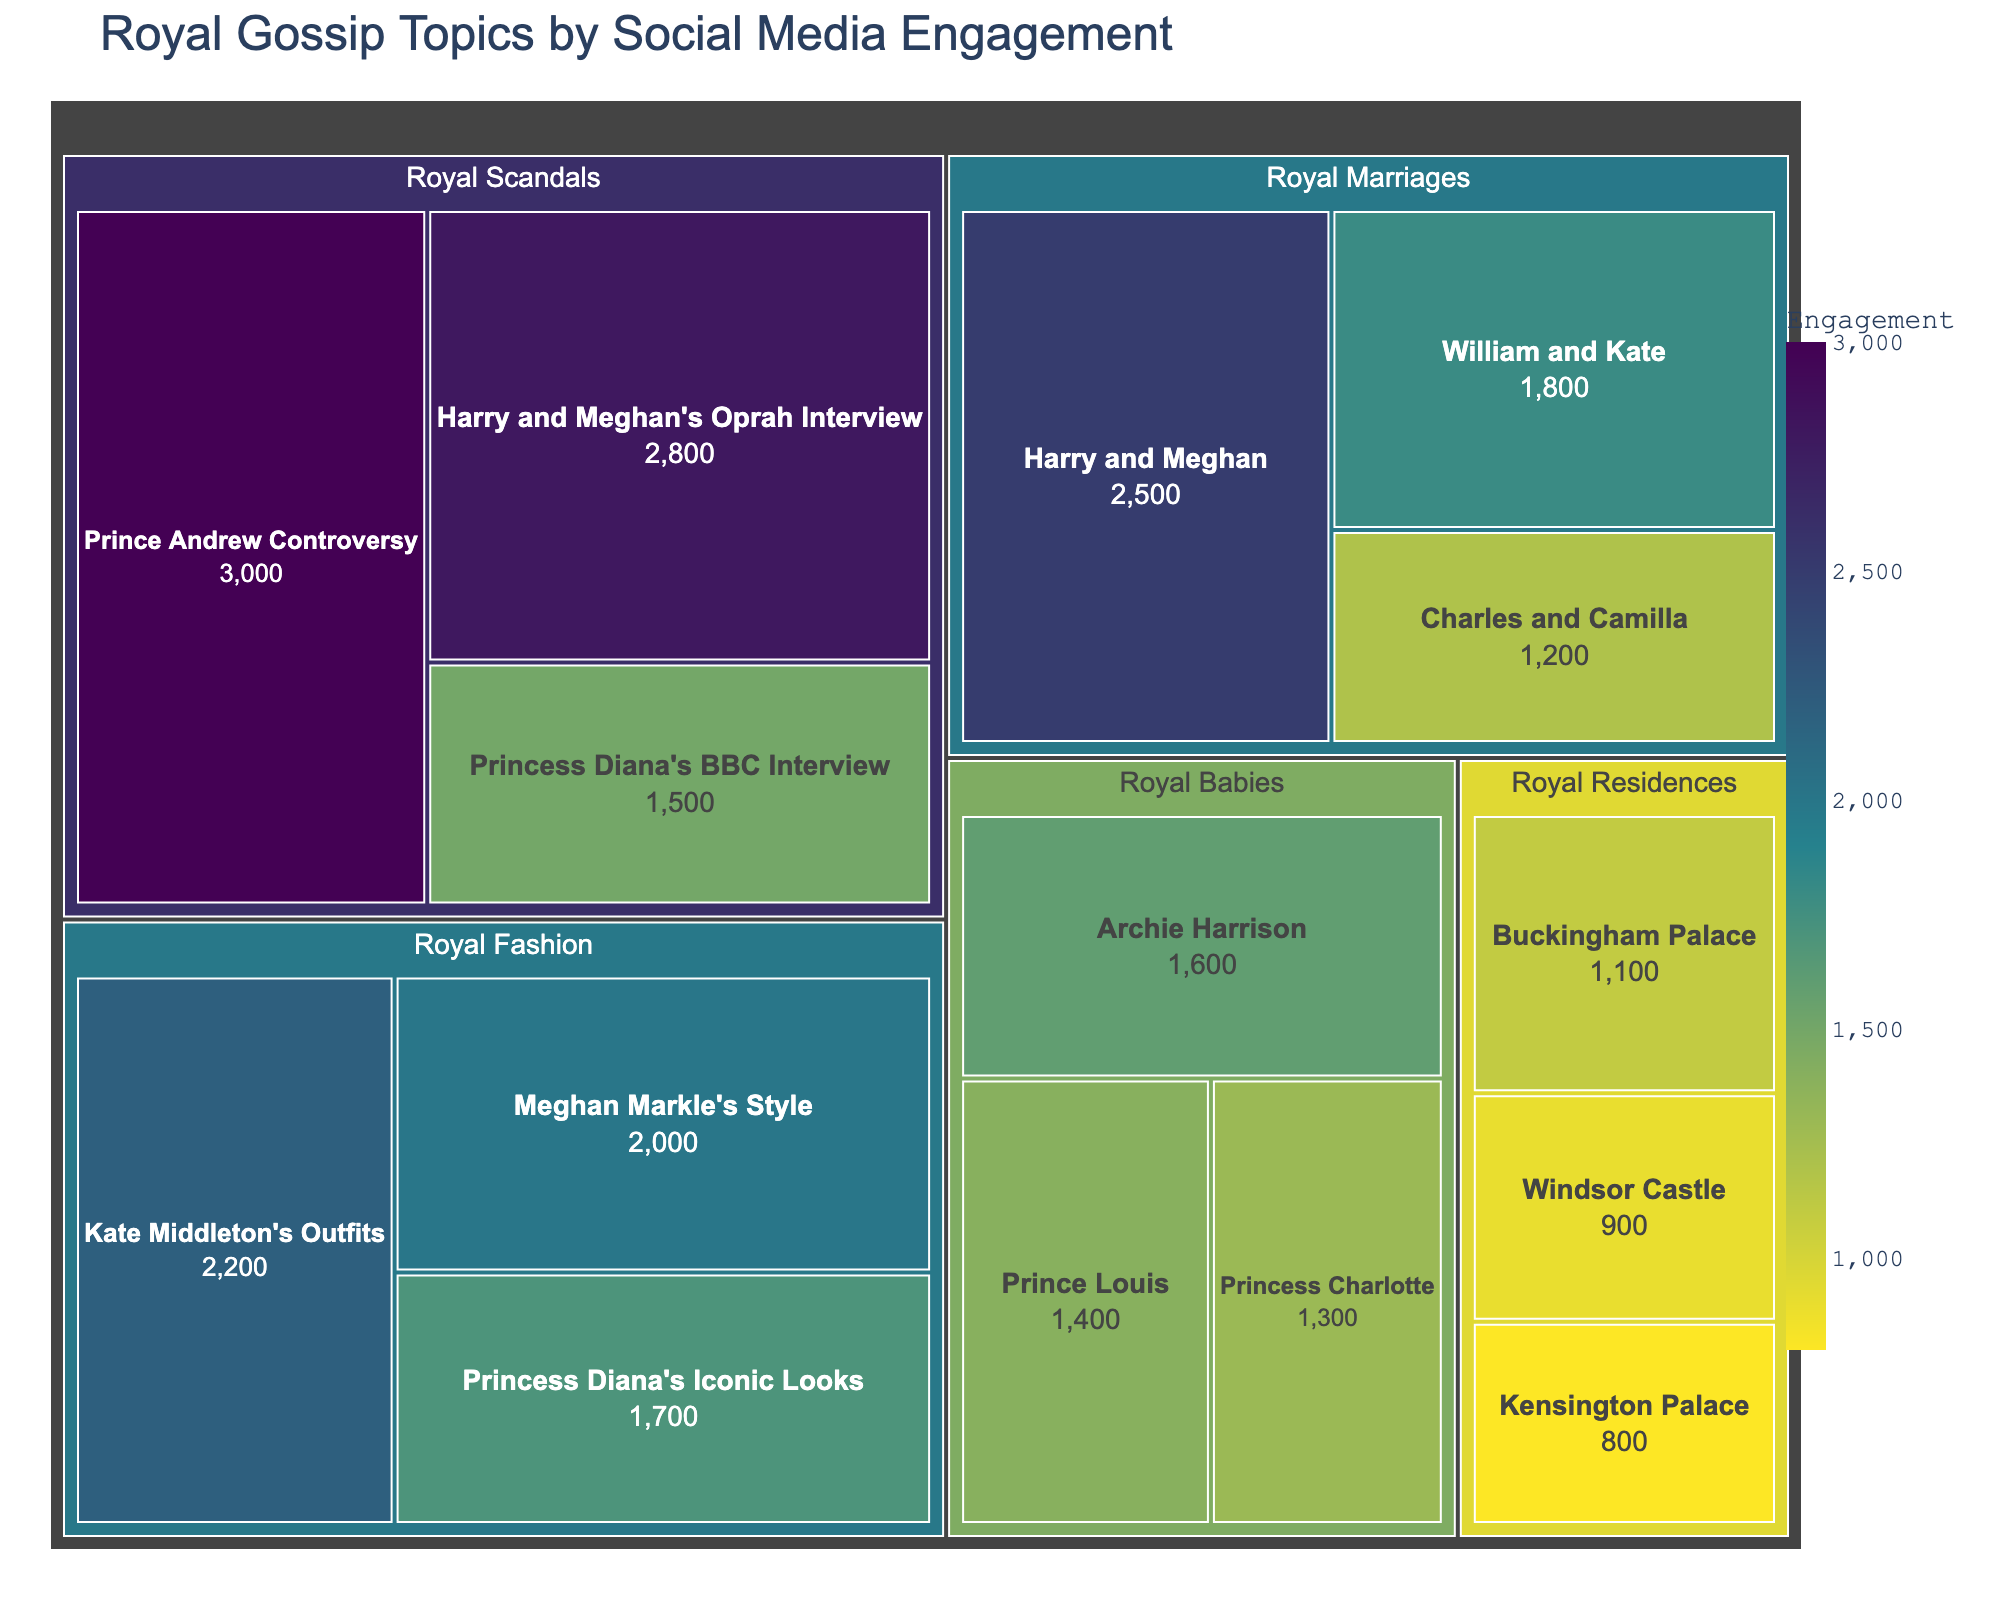What's the title of the treemap? The title is prominently displayed at the top of the treemap and helps to indicate what the data is representing.
Answer: Royal Gossip Topics by Social Media Engagement Which subtopic under "Royal Marriages" has the highest engagement? By looking at the treemap, you can find the subtopic under "Royal Marriages" with the largest size box or the highest value.
Answer: Harry and Meghan What's the total engagement for all "Royal Fashion" subtopics combined? To find the total engagement for "Royal Fashion," sum up the engagements of all its subtopics. (2200 + 2000 + 1700 = 5900)
Answer: 5900 Which subtopic has the lowest engagement in the entire treemap? The subtopic with the smallest box and the smallest engagement value in the treemap is the one with the lowest engagement.
Answer: Kensington Palace What’s the difference in engagement between "Prince Andrew Controversy" and "Princess Diana's BBC Interview"? Subtract the engagement values of "Princess Diana's BBC Interview" from "Prince Andrew Controversy". (3000 - 1500 = 1500)
Answer: 1500 Which topic has the highest total engagement? Sum the engagement values of all subtopics for each main topic and compare the totals.
Answer: Royal Scandals How much more engagement does "Harry and Meghan's Oprah Interview" have compared to "Princess Charlotte"? Subtract the engagement value of "Princess Charlotte" from "Harry and Meghan's Oprah Interview". (2800 - 1300 = 1500)
Answer: 1500 What is the average engagement for subtopics under "Royal Residences"? Sum the engagement values of "Royal Residences" subtopics and divide by the number of subtopics. (1100 + 900 + 800)/3 = 933.33
Answer: 933.33 Which "Royal Babies" subtopic has the least engagement? Look for the smallest box under "Royal Babies" in the treemap, which will indicate the subtopic with the least engagement.
Answer: Princess Charlotte Is "Kate Middleton's Outfits" more engaging than "Meghan Markle's Style"? Compare the engagement values of "Kate Middleton's Outfits" and "Meghan Markle's Style".
Answer: Yes 